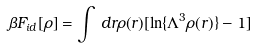Convert formula to latex. <formula><loc_0><loc_0><loc_500><loc_500>\beta F _ { i d } [ \rho ] = \int \, d { r } \rho ( { r } ) [ \ln \{ \Lambda ^ { 3 } \rho ( { r } ) \} - 1 ]</formula> 